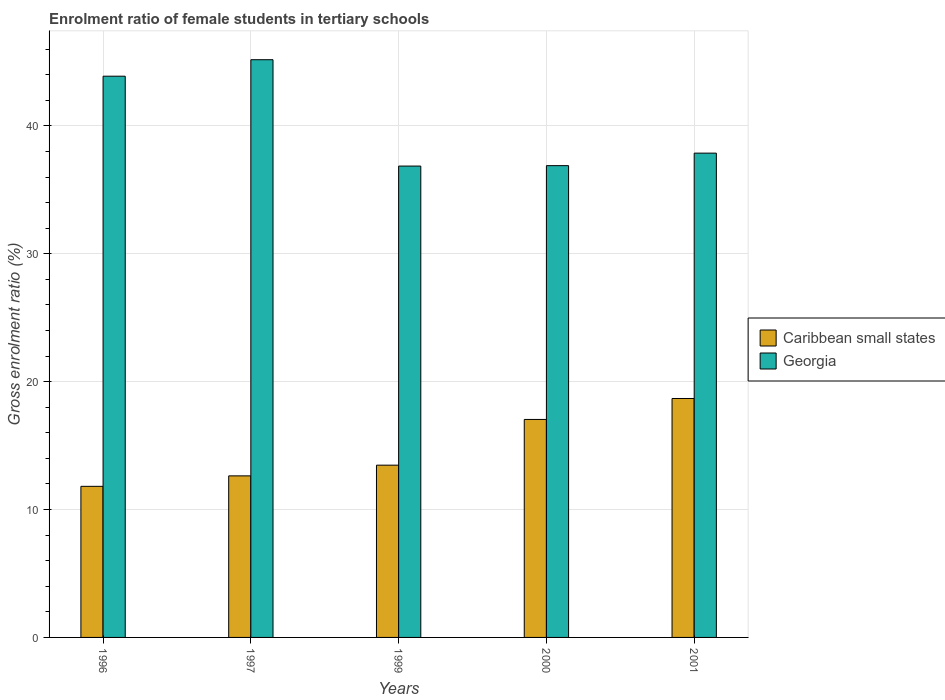How many different coloured bars are there?
Keep it short and to the point. 2. How many groups of bars are there?
Provide a succinct answer. 5. Are the number of bars per tick equal to the number of legend labels?
Give a very brief answer. Yes. What is the label of the 1st group of bars from the left?
Provide a short and direct response. 1996. In how many cases, is the number of bars for a given year not equal to the number of legend labels?
Your response must be concise. 0. What is the enrolment ratio of female students in tertiary schools in Georgia in 2000?
Your answer should be compact. 36.89. Across all years, what is the maximum enrolment ratio of female students in tertiary schools in Caribbean small states?
Your answer should be compact. 18.68. Across all years, what is the minimum enrolment ratio of female students in tertiary schools in Georgia?
Your answer should be compact. 36.86. What is the total enrolment ratio of female students in tertiary schools in Georgia in the graph?
Offer a very short reply. 200.67. What is the difference between the enrolment ratio of female students in tertiary schools in Caribbean small states in 1997 and that in 2000?
Ensure brevity in your answer.  -4.41. What is the difference between the enrolment ratio of female students in tertiary schools in Georgia in 2000 and the enrolment ratio of female students in tertiary schools in Caribbean small states in 1999?
Provide a short and direct response. 23.42. What is the average enrolment ratio of female students in tertiary schools in Georgia per year?
Ensure brevity in your answer.  40.13. In the year 1997, what is the difference between the enrolment ratio of female students in tertiary schools in Georgia and enrolment ratio of female students in tertiary schools in Caribbean small states?
Provide a short and direct response. 32.54. What is the ratio of the enrolment ratio of female students in tertiary schools in Georgia in 1999 to that in 2000?
Offer a terse response. 1. What is the difference between the highest and the second highest enrolment ratio of female students in tertiary schools in Caribbean small states?
Your answer should be compact. 1.64. What is the difference between the highest and the lowest enrolment ratio of female students in tertiary schools in Georgia?
Offer a very short reply. 8.32. In how many years, is the enrolment ratio of female students in tertiary schools in Georgia greater than the average enrolment ratio of female students in tertiary schools in Georgia taken over all years?
Provide a short and direct response. 2. What does the 1st bar from the left in 2001 represents?
Make the answer very short. Caribbean small states. What does the 2nd bar from the right in 2001 represents?
Your answer should be very brief. Caribbean small states. Are all the bars in the graph horizontal?
Ensure brevity in your answer.  No. How many years are there in the graph?
Your answer should be very brief. 5. What is the difference between two consecutive major ticks on the Y-axis?
Ensure brevity in your answer.  10. Does the graph contain grids?
Make the answer very short. Yes. Where does the legend appear in the graph?
Your answer should be very brief. Center right. How many legend labels are there?
Your response must be concise. 2. How are the legend labels stacked?
Your answer should be very brief. Vertical. What is the title of the graph?
Keep it short and to the point. Enrolment ratio of female students in tertiary schools. Does "Low & middle income" appear as one of the legend labels in the graph?
Keep it short and to the point. No. What is the label or title of the X-axis?
Offer a terse response. Years. What is the label or title of the Y-axis?
Make the answer very short. Gross enrolment ratio (%). What is the Gross enrolment ratio (%) in Caribbean small states in 1996?
Your response must be concise. 11.81. What is the Gross enrolment ratio (%) in Georgia in 1996?
Offer a very short reply. 43.88. What is the Gross enrolment ratio (%) in Caribbean small states in 1997?
Offer a terse response. 12.63. What is the Gross enrolment ratio (%) of Georgia in 1997?
Offer a terse response. 45.17. What is the Gross enrolment ratio (%) of Caribbean small states in 1999?
Your answer should be very brief. 13.47. What is the Gross enrolment ratio (%) of Georgia in 1999?
Ensure brevity in your answer.  36.86. What is the Gross enrolment ratio (%) in Caribbean small states in 2000?
Offer a terse response. 17.04. What is the Gross enrolment ratio (%) in Georgia in 2000?
Give a very brief answer. 36.89. What is the Gross enrolment ratio (%) in Caribbean small states in 2001?
Keep it short and to the point. 18.68. What is the Gross enrolment ratio (%) of Georgia in 2001?
Your answer should be very brief. 37.87. Across all years, what is the maximum Gross enrolment ratio (%) in Caribbean small states?
Your answer should be very brief. 18.68. Across all years, what is the maximum Gross enrolment ratio (%) of Georgia?
Give a very brief answer. 45.17. Across all years, what is the minimum Gross enrolment ratio (%) in Caribbean small states?
Ensure brevity in your answer.  11.81. Across all years, what is the minimum Gross enrolment ratio (%) in Georgia?
Keep it short and to the point. 36.86. What is the total Gross enrolment ratio (%) in Caribbean small states in the graph?
Your answer should be compact. 73.64. What is the total Gross enrolment ratio (%) in Georgia in the graph?
Offer a very short reply. 200.67. What is the difference between the Gross enrolment ratio (%) of Caribbean small states in 1996 and that in 1997?
Your response must be concise. -0.82. What is the difference between the Gross enrolment ratio (%) in Georgia in 1996 and that in 1997?
Your response must be concise. -1.29. What is the difference between the Gross enrolment ratio (%) of Caribbean small states in 1996 and that in 1999?
Give a very brief answer. -1.66. What is the difference between the Gross enrolment ratio (%) in Georgia in 1996 and that in 1999?
Make the answer very short. 7.03. What is the difference between the Gross enrolment ratio (%) of Caribbean small states in 1996 and that in 2000?
Offer a very short reply. -5.23. What is the difference between the Gross enrolment ratio (%) of Georgia in 1996 and that in 2000?
Provide a short and direct response. 6.99. What is the difference between the Gross enrolment ratio (%) of Caribbean small states in 1996 and that in 2001?
Give a very brief answer. -6.87. What is the difference between the Gross enrolment ratio (%) of Georgia in 1996 and that in 2001?
Your answer should be compact. 6.02. What is the difference between the Gross enrolment ratio (%) of Caribbean small states in 1997 and that in 1999?
Give a very brief answer. -0.84. What is the difference between the Gross enrolment ratio (%) of Georgia in 1997 and that in 1999?
Your answer should be very brief. 8.32. What is the difference between the Gross enrolment ratio (%) in Caribbean small states in 1997 and that in 2000?
Your answer should be compact. -4.41. What is the difference between the Gross enrolment ratio (%) in Georgia in 1997 and that in 2000?
Provide a succinct answer. 8.28. What is the difference between the Gross enrolment ratio (%) in Caribbean small states in 1997 and that in 2001?
Your answer should be compact. -6.05. What is the difference between the Gross enrolment ratio (%) in Georgia in 1997 and that in 2001?
Your answer should be compact. 7.31. What is the difference between the Gross enrolment ratio (%) in Caribbean small states in 1999 and that in 2000?
Provide a succinct answer. -3.57. What is the difference between the Gross enrolment ratio (%) in Georgia in 1999 and that in 2000?
Make the answer very short. -0.03. What is the difference between the Gross enrolment ratio (%) in Caribbean small states in 1999 and that in 2001?
Your answer should be compact. -5.21. What is the difference between the Gross enrolment ratio (%) in Georgia in 1999 and that in 2001?
Offer a very short reply. -1.01. What is the difference between the Gross enrolment ratio (%) in Caribbean small states in 2000 and that in 2001?
Your answer should be compact. -1.64. What is the difference between the Gross enrolment ratio (%) of Georgia in 2000 and that in 2001?
Provide a succinct answer. -0.98. What is the difference between the Gross enrolment ratio (%) in Caribbean small states in 1996 and the Gross enrolment ratio (%) in Georgia in 1997?
Provide a short and direct response. -33.36. What is the difference between the Gross enrolment ratio (%) of Caribbean small states in 1996 and the Gross enrolment ratio (%) of Georgia in 1999?
Keep it short and to the point. -25.04. What is the difference between the Gross enrolment ratio (%) of Caribbean small states in 1996 and the Gross enrolment ratio (%) of Georgia in 2000?
Offer a terse response. -25.08. What is the difference between the Gross enrolment ratio (%) of Caribbean small states in 1996 and the Gross enrolment ratio (%) of Georgia in 2001?
Offer a very short reply. -26.05. What is the difference between the Gross enrolment ratio (%) of Caribbean small states in 1997 and the Gross enrolment ratio (%) of Georgia in 1999?
Give a very brief answer. -24.22. What is the difference between the Gross enrolment ratio (%) of Caribbean small states in 1997 and the Gross enrolment ratio (%) of Georgia in 2000?
Provide a short and direct response. -24.26. What is the difference between the Gross enrolment ratio (%) of Caribbean small states in 1997 and the Gross enrolment ratio (%) of Georgia in 2001?
Provide a short and direct response. -25.23. What is the difference between the Gross enrolment ratio (%) of Caribbean small states in 1999 and the Gross enrolment ratio (%) of Georgia in 2000?
Provide a succinct answer. -23.42. What is the difference between the Gross enrolment ratio (%) of Caribbean small states in 1999 and the Gross enrolment ratio (%) of Georgia in 2001?
Provide a short and direct response. -24.4. What is the difference between the Gross enrolment ratio (%) in Caribbean small states in 2000 and the Gross enrolment ratio (%) in Georgia in 2001?
Provide a short and direct response. -20.82. What is the average Gross enrolment ratio (%) in Caribbean small states per year?
Provide a succinct answer. 14.73. What is the average Gross enrolment ratio (%) in Georgia per year?
Offer a terse response. 40.13. In the year 1996, what is the difference between the Gross enrolment ratio (%) in Caribbean small states and Gross enrolment ratio (%) in Georgia?
Provide a short and direct response. -32.07. In the year 1997, what is the difference between the Gross enrolment ratio (%) in Caribbean small states and Gross enrolment ratio (%) in Georgia?
Your response must be concise. -32.54. In the year 1999, what is the difference between the Gross enrolment ratio (%) of Caribbean small states and Gross enrolment ratio (%) of Georgia?
Make the answer very short. -23.39. In the year 2000, what is the difference between the Gross enrolment ratio (%) in Caribbean small states and Gross enrolment ratio (%) in Georgia?
Offer a terse response. -19.85. In the year 2001, what is the difference between the Gross enrolment ratio (%) of Caribbean small states and Gross enrolment ratio (%) of Georgia?
Provide a short and direct response. -19.18. What is the ratio of the Gross enrolment ratio (%) of Caribbean small states in 1996 to that in 1997?
Give a very brief answer. 0.94. What is the ratio of the Gross enrolment ratio (%) of Georgia in 1996 to that in 1997?
Give a very brief answer. 0.97. What is the ratio of the Gross enrolment ratio (%) of Caribbean small states in 1996 to that in 1999?
Your answer should be very brief. 0.88. What is the ratio of the Gross enrolment ratio (%) in Georgia in 1996 to that in 1999?
Your answer should be compact. 1.19. What is the ratio of the Gross enrolment ratio (%) of Caribbean small states in 1996 to that in 2000?
Provide a short and direct response. 0.69. What is the ratio of the Gross enrolment ratio (%) in Georgia in 1996 to that in 2000?
Offer a very short reply. 1.19. What is the ratio of the Gross enrolment ratio (%) of Caribbean small states in 1996 to that in 2001?
Give a very brief answer. 0.63. What is the ratio of the Gross enrolment ratio (%) of Georgia in 1996 to that in 2001?
Keep it short and to the point. 1.16. What is the ratio of the Gross enrolment ratio (%) in Caribbean small states in 1997 to that in 1999?
Offer a terse response. 0.94. What is the ratio of the Gross enrolment ratio (%) of Georgia in 1997 to that in 1999?
Keep it short and to the point. 1.23. What is the ratio of the Gross enrolment ratio (%) of Caribbean small states in 1997 to that in 2000?
Your answer should be compact. 0.74. What is the ratio of the Gross enrolment ratio (%) in Georgia in 1997 to that in 2000?
Give a very brief answer. 1.22. What is the ratio of the Gross enrolment ratio (%) in Caribbean small states in 1997 to that in 2001?
Give a very brief answer. 0.68. What is the ratio of the Gross enrolment ratio (%) in Georgia in 1997 to that in 2001?
Ensure brevity in your answer.  1.19. What is the ratio of the Gross enrolment ratio (%) of Caribbean small states in 1999 to that in 2000?
Provide a succinct answer. 0.79. What is the ratio of the Gross enrolment ratio (%) in Georgia in 1999 to that in 2000?
Your answer should be very brief. 1. What is the ratio of the Gross enrolment ratio (%) of Caribbean small states in 1999 to that in 2001?
Provide a succinct answer. 0.72. What is the ratio of the Gross enrolment ratio (%) of Georgia in 1999 to that in 2001?
Your answer should be compact. 0.97. What is the ratio of the Gross enrolment ratio (%) of Caribbean small states in 2000 to that in 2001?
Give a very brief answer. 0.91. What is the ratio of the Gross enrolment ratio (%) in Georgia in 2000 to that in 2001?
Keep it short and to the point. 0.97. What is the difference between the highest and the second highest Gross enrolment ratio (%) of Caribbean small states?
Your answer should be very brief. 1.64. What is the difference between the highest and the second highest Gross enrolment ratio (%) of Georgia?
Offer a terse response. 1.29. What is the difference between the highest and the lowest Gross enrolment ratio (%) in Caribbean small states?
Provide a short and direct response. 6.87. What is the difference between the highest and the lowest Gross enrolment ratio (%) of Georgia?
Your response must be concise. 8.32. 